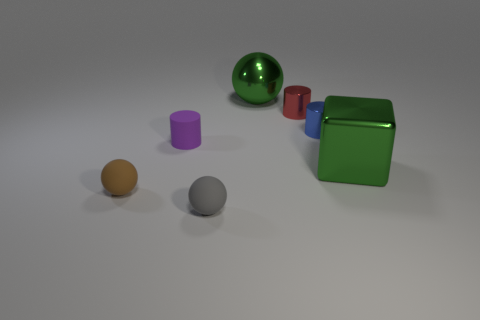Add 3 tiny red things. How many objects exist? 10 Subtract all blocks. How many objects are left? 6 Add 7 blue metallic things. How many blue metallic things exist? 8 Subtract 0 purple blocks. How many objects are left? 7 Subtract all blue metal cylinders. Subtract all metal cylinders. How many objects are left? 4 Add 7 tiny metallic objects. How many tiny metallic objects are left? 9 